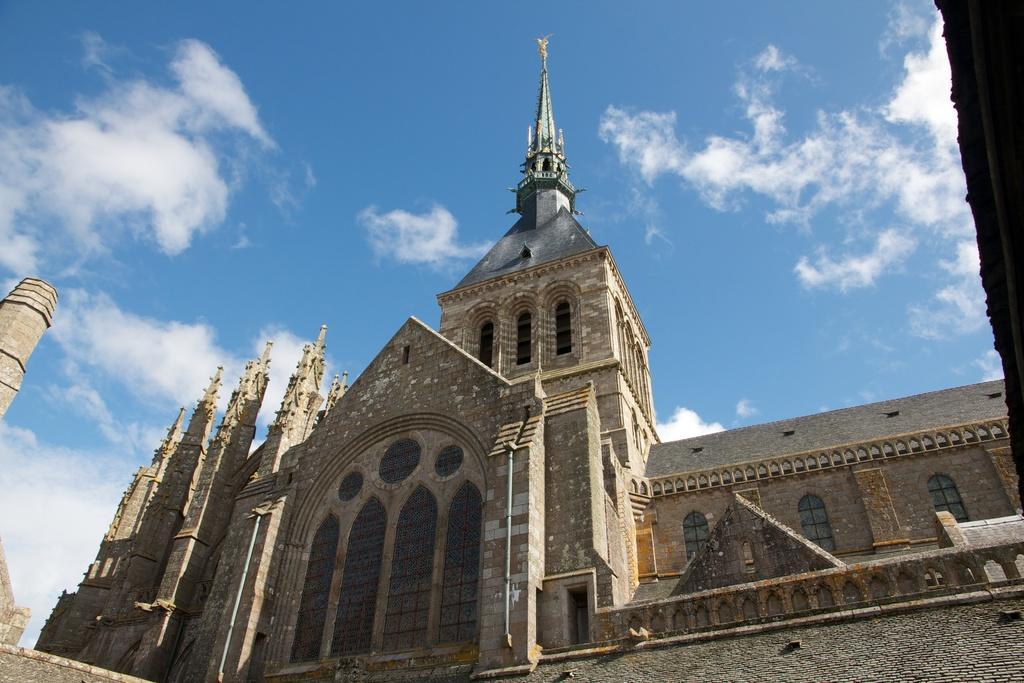Can you describe this image briefly? This image consists of a building. It looks like a church. At the top, there are clouds in the sky. 